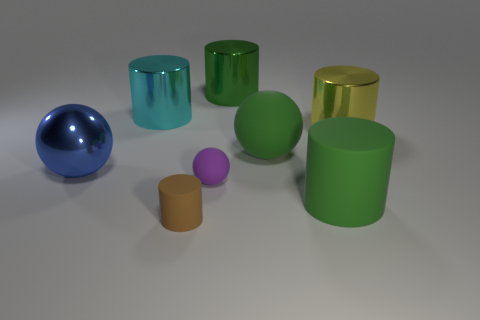Subtract all rubber balls. How many balls are left? 1 Add 2 rubber cylinders. How many objects exist? 10 Subtract all green cylinders. How many cylinders are left? 3 Subtract 3 cylinders. How many cylinders are left? 2 Subtract all yellow balls. Subtract all brown cubes. How many balls are left? 3 Subtract all cylinders. How many objects are left? 3 Add 2 big yellow shiny objects. How many big yellow shiny objects exist? 3 Subtract 1 purple spheres. How many objects are left? 7 Subtract all large yellow metallic cubes. Subtract all purple things. How many objects are left? 7 Add 4 rubber things. How many rubber things are left? 8 